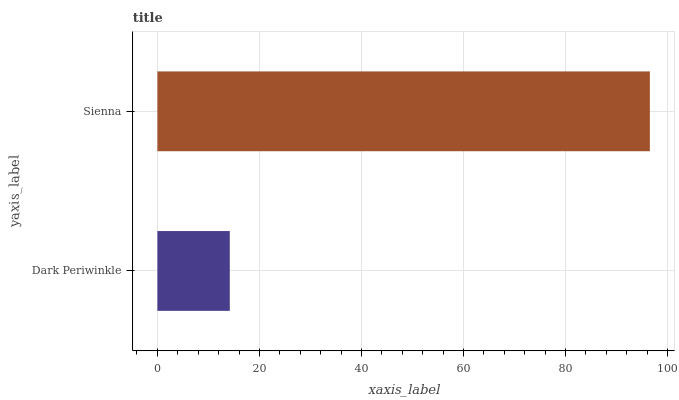Is Dark Periwinkle the minimum?
Answer yes or no. Yes. Is Sienna the maximum?
Answer yes or no. Yes. Is Sienna the minimum?
Answer yes or no. No. Is Sienna greater than Dark Periwinkle?
Answer yes or no. Yes. Is Dark Periwinkle less than Sienna?
Answer yes or no. Yes. Is Dark Periwinkle greater than Sienna?
Answer yes or no. No. Is Sienna less than Dark Periwinkle?
Answer yes or no. No. Is Sienna the high median?
Answer yes or no. Yes. Is Dark Periwinkle the low median?
Answer yes or no. Yes. Is Dark Periwinkle the high median?
Answer yes or no. No. Is Sienna the low median?
Answer yes or no. No. 